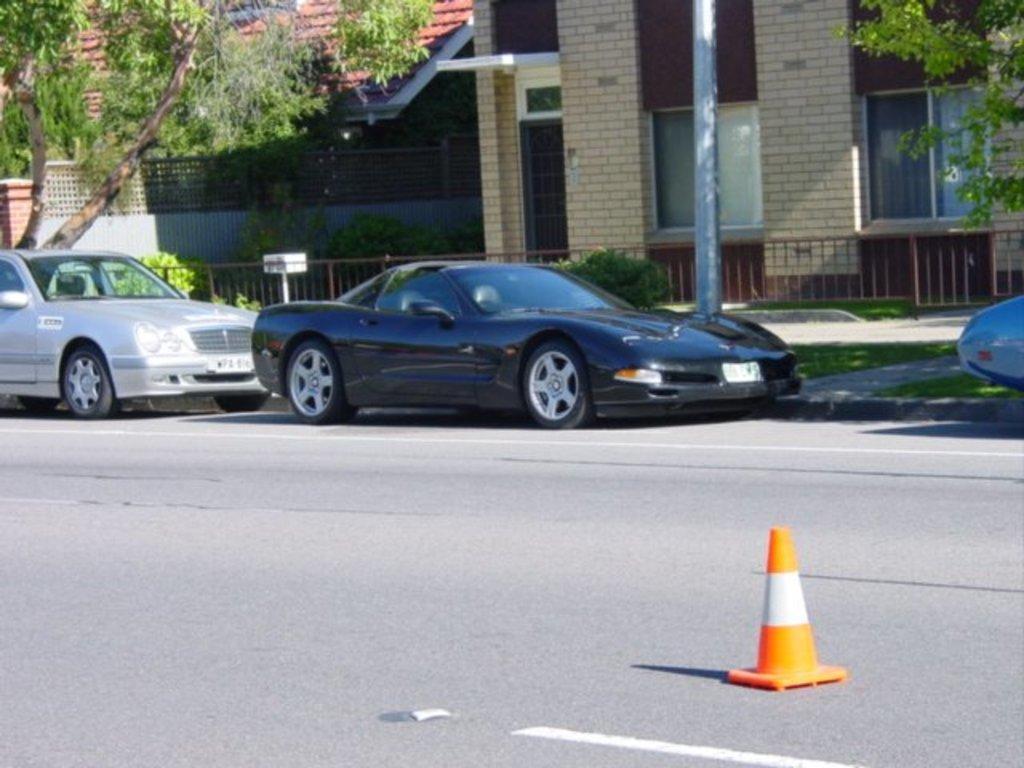How would you summarize this image in a sentence or two? In this image there are cars on the road. There is a traffic cone cup. There is a metal fence. There is a pole. In the background of the image there are buildings, trees. 